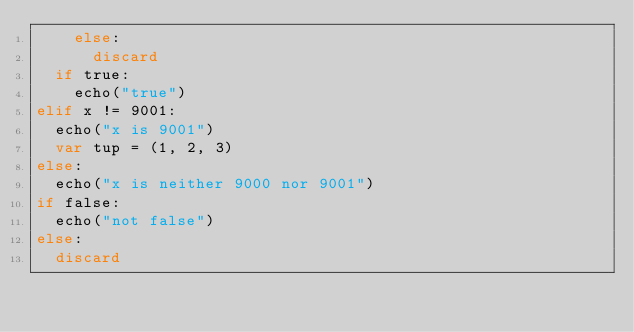<code> <loc_0><loc_0><loc_500><loc_500><_Nim_>    else:
      discard
  if true:
    echo("true")
elif x != 9001:
  echo("x is 9001")
  var tup = (1, 2, 3)
else:
  echo("x is neither 9000 nor 9001")
if false:
  echo("not false")
else:
  discard</code> 